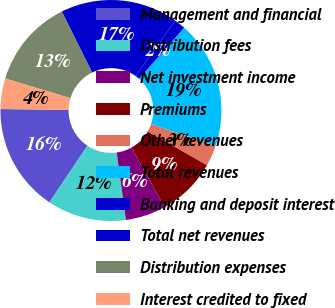Convert chart to OTSL. <chart><loc_0><loc_0><loc_500><loc_500><pie_chart><fcel>Management and financial<fcel>Distribution fees<fcel>Net investment income<fcel>Premiums<fcel>Other revenues<fcel>Total revenues<fcel>Banking and deposit interest<fcel>Total net revenues<fcel>Distribution expenses<fcel>Interest credited to fixed<nl><fcel>15.82%<fcel>11.56%<fcel>5.89%<fcel>8.72%<fcel>3.05%<fcel>18.65%<fcel>1.63%<fcel>17.23%<fcel>12.98%<fcel>4.47%<nl></chart> 